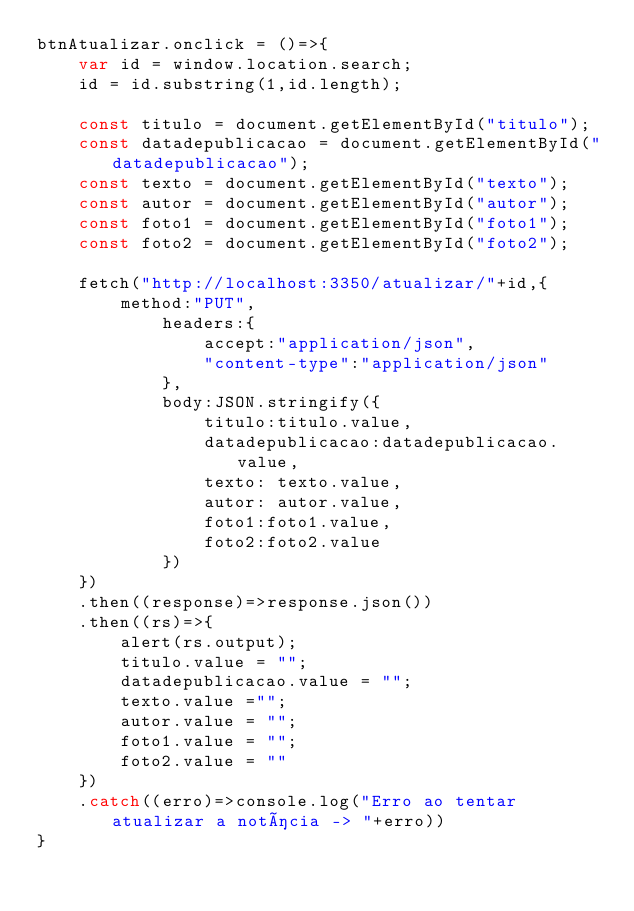Convert code to text. <code><loc_0><loc_0><loc_500><loc_500><_JavaScript_>btnAtualizar.onclick = ()=>{
    var id = window.location.search;
    id = id.substring(1,id.length);

    const titulo = document.getElementById("titulo");
    const datadepublicacao = document.getElementById("datadepublicacao");
    const texto = document.getElementById("texto");
    const autor = document.getElementById("autor");
    const foto1 = document.getElementById("foto1");
    const foto2 = document.getElementById("foto2");

    fetch("http://localhost:3350/atualizar/"+id,{
        method:"PUT",
            headers:{
                accept:"application/json",
                "content-type":"application/json"
            },
            body:JSON.stringify({
                titulo:titulo.value,
                datadepublicacao:datadepublicacao.value,
                texto: texto.value,
                autor: autor.value,
                foto1:foto1.value,
                foto2:foto2.value
            })
    })
    .then((response)=>response.json())
    .then((rs)=>{
        alert(rs.output);
        titulo.value = "";
        datadepublicacao.value = "";
        texto.value ="";
        autor.value = "";
        foto1.value = "";
        foto2.value = ""
    })
    .catch((erro)=>console.log("Erro ao tentar atualizar a notícia -> "+erro))
}
</code> 